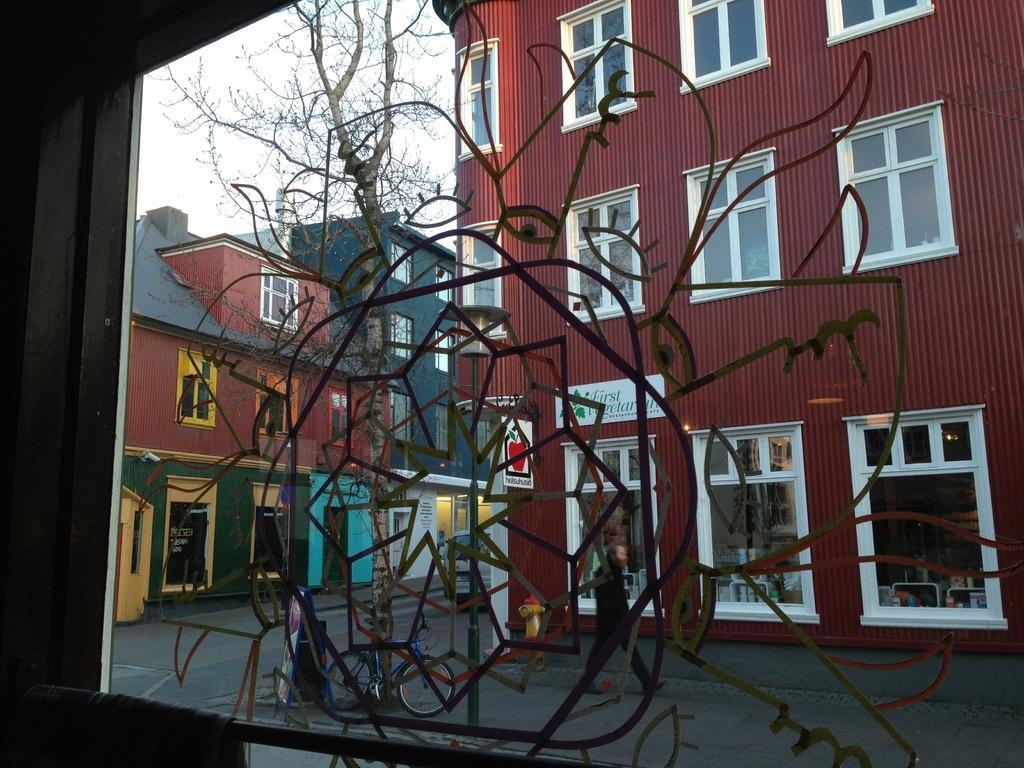In one or two sentences, can you explain what this image depicts? In the image there are buildings in the back with windows all over it , this is clicked inside a building, there is an art in front of the window and behind it there is a tree in the middle with cycle in front of it. 